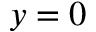Convert formula to latex. <formula><loc_0><loc_0><loc_500><loc_500>y = 0</formula> 